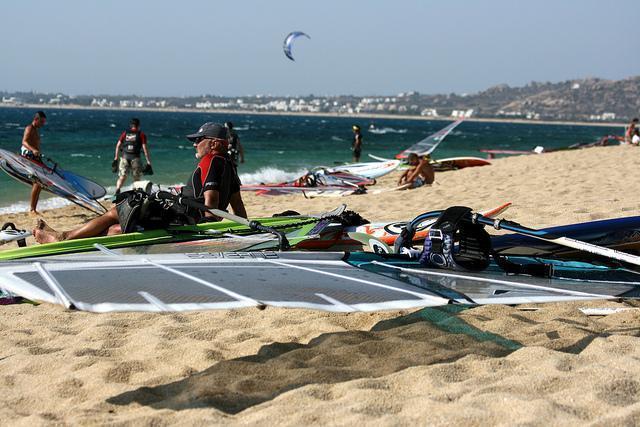Where is the person holding the sail seen here standing?
Select the accurate response from the four choices given to answer the question.
Options: Whale's back, roadway, ocean, beach. Ocean. 